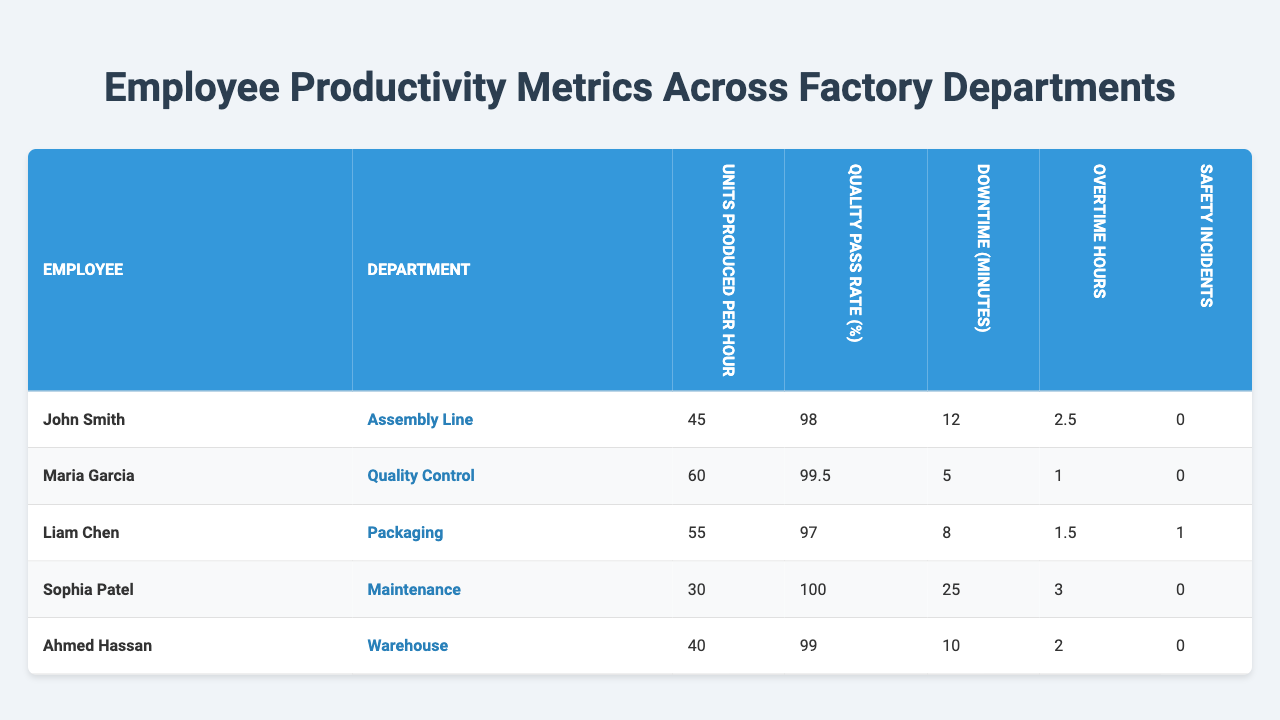What is the highest Quality Pass Rate among the employees? The Quality Pass Rate (%) for each employee is listed in the table. We can identify the highest value which is Maria Garcia with a Quality Pass Rate of 99.5%.
Answer: 99.5% Which employee produced the most units per hour? The Units Produced Per Hour for each employee are shown in the table. The highest value is 60 units per hour, produced by Maria Garcia.
Answer: Maria Garcia How many safety incidents occurred in total across all employees? By reviewing the Safety Incidents column, we add up the numbers: 0 (John Smith) + 0 (Maria Garcia) + 1 (Liam Chen) + 0 (Sophia Patel) + 0 (Ahmed Hassan) = 1 total safety incident.
Answer: 1 What is the average downtime across all employee departments? The Downtime (minutes) for each employee is: 12, 5, 8, 25, and 10. Sum these values (12 + 5 + 8 + 25 + 10 = 60) and divide by the number of employees (5), resulting in an average of 12 minutes.
Answer: 12 minutes Is there any employee with zero safety incidents? Review the Safety Incidents column; John Smith, Maria Garcia, Sophia Patel, and Ahmed Hassan all have zero safety incidents, confirming that there are employees with no reported incidents.
Answer: Yes Which department had the least units produced per hour? The Units Produced Per Hour for each department are as follows: Assembly Line (45), Quality Control (60), Packaging (55), Maintenance (30), and Warehouse (40). The lowest of these values is from the Maintenance department with 30 units per hour.
Answer: Maintenance How many total overtime hours did employees work? Adding together the Overtime Hours for all employees: 2.5 (John Smith) + 1 (Maria Garcia) + 1.5 (Liam Chen) + 3 (Sophia Patel) + 2 (Ahmed Hassan) gives us a total of 10 hours.
Answer: 10 hours Which employee worked the most overtime hours? The Overtime Hours for each employee are 2.5, 1, 1.5, 3, and 2. The highest value is 3 hours worked by Sophia Patel.
Answer: Sophia Patel What is the difference in productivity (units produced per hour) between the best and worst employee? The best and worst performance in terms of units produced per hour is Maria Garcia (60) and Sophia Patel (30). The difference is 60 - 30 = 30 units per hour.
Answer: 30 units per hour Which department had the highest average Quality Pass Rate? The Quality Pass Rates (%) for each department are: Assembly Line (98), Quality Control (99.5), Packaging (97), Maintenance (100), and Warehouse (99). The average Quality Pass Rate for each can be calculated, but noticing the highest single value, Maintenance has the highest quality pass rate at 100%.
Answer: Maintenance 